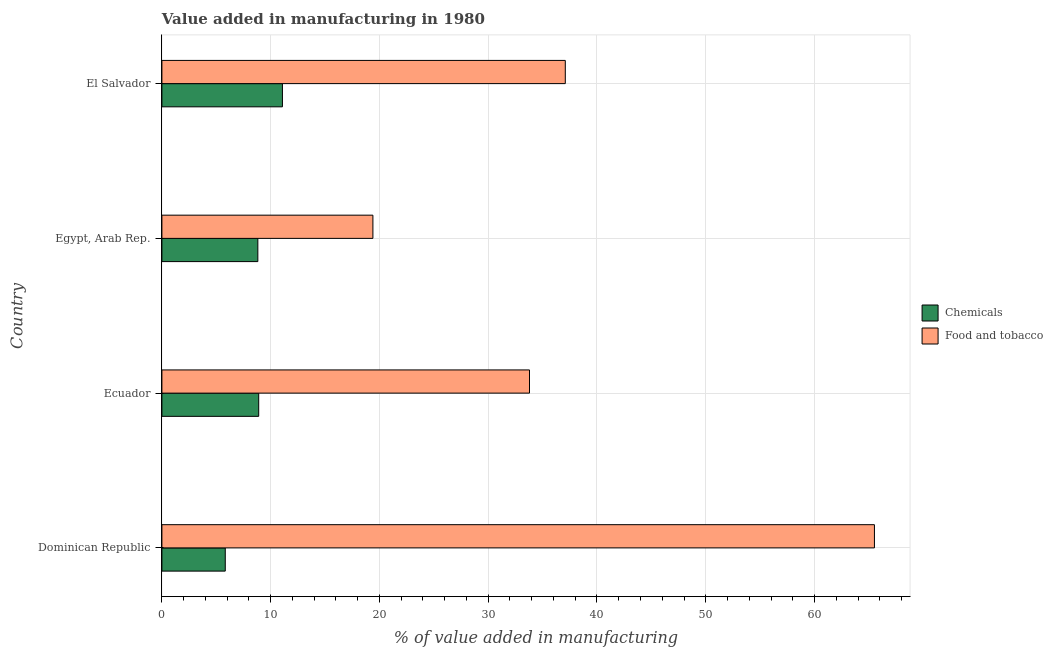How many groups of bars are there?
Make the answer very short. 4. Are the number of bars per tick equal to the number of legend labels?
Your answer should be compact. Yes. Are the number of bars on each tick of the Y-axis equal?
Your answer should be very brief. Yes. How many bars are there on the 1st tick from the top?
Your answer should be very brief. 2. What is the label of the 3rd group of bars from the top?
Offer a terse response. Ecuador. What is the value added by manufacturing food and tobacco in Egypt, Arab Rep.?
Provide a succinct answer. 19.4. Across all countries, what is the maximum value added by  manufacturing chemicals?
Offer a very short reply. 11.08. Across all countries, what is the minimum value added by  manufacturing chemicals?
Ensure brevity in your answer.  5.83. In which country was the value added by manufacturing food and tobacco maximum?
Ensure brevity in your answer.  Dominican Republic. In which country was the value added by  manufacturing chemicals minimum?
Your response must be concise. Dominican Republic. What is the total value added by  manufacturing chemicals in the graph?
Offer a very short reply. 34.63. What is the difference between the value added by manufacturing food and tobacco in Dominican Republic and that in Ecuador?
Keep it short and to the point. 31.71. What is the difference between the value added by manufacturing food and tobacco in Ecuador and the value added by  manufacturing chemicals in Egypt, Arab Rep.?
Provide a short and direct response. 24.98. What is the average value added by manufacturing food and tobacco per country?
Keep it short and to the point. 38.95. What is the difference between the value added by  manufacturing chemicals and value added by manufacturing food and tobacco in Egypt, Arab Rep.?
Offer a very short reply. -10.58. In how many countries, is the value added by  manufacturing chemicals greater than 56 %?
Your answer should be very brief. 0. What is the ratio of the value added by manufacturing food and tobacco in Dominican Republic to that in Ecuador?
Offer a terse response. 1.94. Is the value added by manufacturing food and tobacco in Dominican Republic less than that in Ecuador?
Your response must be concise. No. Is the difference between the value added by  manufacturing chemicals in Ecuador and Egypt, Arab Rep. greater than the difference between the value added by manufacturing food and tobacco in Ecuador and Egypt, Arab Rep.?
Provide a succinct answer. No. What is the difference between the highest and the second highest value added by manufacturing food and tobacco?
Make the answer very short. 28.42. What is the difference between the highest and the lowest value added by  manufacturing chemicals?
Give a very brief answer. 5.26. In how many countries, is the value added by  manufacturing chemicals greater than the average value added by  manufacturing chemicals taken over all countries?
Ensure brevity in your answer.  3. What does the 1st bar from the top in El Salvador represents?
Give a very brief answer. Food and tobacco. What does the 2nd bar from the bottom in Ecuador represents?
Your answer should be very brief. Food and tobacco. How many countries are there in the graph?
Ensure brevity in your answer.  4. What is the difference between two consecutive major ticks on the X-axis?
Make the answer very short. 10. Does the graph contain grids?
Make the answer very short. Yes. How many legend labels are there?
Keep it short and to the point. 2. How are the legend labels stacked?
Offer a very short reply. Vertical. What is the title of the graph?
Your answer should be very brief. Value added in manufacturing in 1980. What is the label or title of the X-axis?
Provide a succinct answer. % of value added in manufacturing. What is the label or title of the Y-axis?
Offer a very short reply. Country. What is the % of value added in manufacturing in Chemicals in Dominican Republic?
Offer a very short reply. 5.83. What is the % of value added in manufacturing in Food and tobacco in Dominican Republic?
Keep it short and to the point. 65.51. What is the % of value added in manufacturing in Chemicals in Ecuador?
Make the answer very short. 8.9. What is the % of value added in manufacturing in Food and tobacco in Ecuador?
Your answer should be compact. 33.8. What is the % of value added in manufacturing of Chemicals in Egypt, Arab Rep.?
Offer a very short reply. 8.82. What is the % of value added in manufacturing in Food and tobacco in Egypt, Arab Rep.?
Provide a short and direct response. 19.4. What is the % of value added in manufacturing of Chemicals in El Salvador?
Your response must be concise. 11.08. What is the % of value added in manufacturing of Food and tobacco in El Salvador?
Give a very brief answer. 37.09. Across all countries, what is the maximum % of value added in manufacturing in Chemicals?
Provide a short and direct response. 11.08. Across all countries, what is the maximum % of value added in manufacturing in Food and tobacco?
Offer a very short reply. 65.51. Across all countries, what is the minimum % of value added in manufacturing of Chemicals?
Give a very brief answer. 5.83. Across all countries, what is the minimum % of value added in manufacturing in Food and tobacco?
Give a very brief answer. 19.4. What is the total % of value added in manufacturing in Chemicals in the graph?
Offer a very short reply. 34.63. What is the total % of value added in manufacturing in Food and tobacco in the graph?
Give a very brief answer. 155.79. What is the difference between the % of value added in manufacturing in Chemicals in Dominican Republic and that in Ecuador?
Your response must be concise. -3.07. What is the difference between the % of value added in manufacturing of Food and tobacco in Dominican Republic and that in Ecuador?
Offer a terse response. 31.71. What is the difference between the % of value added in manufacturing in Chemicals in Dominican Republic and that in Egypt, Arab Rep.?
Keep it short and to the point. -3. What is the difference between the % of value added in manufacturing in Food and tobacco in Dominican Republic and that in Egypt, Arab Rep.?
Make the answer very short. 46.11. What is the difference between the % of value added in manufacturing of Chemicals in Dominican Republic and that in El Salvador?
Your answer should be compact. -5.26. What is the difference between the % of value added in manufacturing of Food and tobacco in Dominican Republic and that in El Salvador?
Your response must be concise. 28.42. What is the difference between the % of value added in manufacturing in Chemicals in Ecuador and that in Egypt, Arab Rep.?
Offer a very short reply. 0.08. What is the difference between the % of value added in manufacturing in Food and tobacco in Ecuador and that in Egypt, Arab Rep.?
Offer a terse response. 14.4. What is the difference between the % of value added in manufacturing of Chemicals in Ecuador and that in El Salvador?
Offer a very short reply. -2.18. What is the difference between the % of value added in manufacturing in Food and tobacco in Ecuador and that in El Salvador?
Your answer should be very brief. -3.29. What is the difference between the % of value added in manufacturing of Chemicals in Egypt, Arab Rep. and that in El Salvador?
Give a very brief answer. -2.26. What is the difference between the % of value added in manufacturing in Food and tobacco in Egypt, Arab Rep. and that in El Salvador?
Your answer should be very brief. -17.69. What is the difference between the % of value added in manufacturing in Chemicals in Dominican Republic and the % of value added in manufacturing in Food and tobacco in Ecuador?
Your answer should be compact. -27.97. What is the difference between the % of value added in manufacturing in Chemicals in Dominican Republic and the % of value added in manufacturing in Food and tobacco in Egypt, Arab Rep.?
Offer a very short reply. -13.57. What is the difference between the % of value added in manufacturing of Chemicals in Dominican Republic and the % of value added in manufacturing of Food and tobacco in El Salvador?
Your answer should be very brief. -31.26. What is the difference between the % of value added in manufacturing in Chemicals in Ecuador and the % of value added in manufacturing in Food and tobacco in Egypt, Arab Rep.?
Ensure brevity in your answer.  -10.5. What is the difference between the % of value added in manufacturing of Chemicals in Ecuador and the % of value added in manufacturing of Food and tobacco in El Salvador?
Make the answer very short. -28.19. What is the difference between the % of value added in manufacturing of Chemicals in Egypt, Arab Rep. and the % of value added in manufacturing of Food and tobacco in El Salvador?
Provide a short and direct response. -28.27. What is the average % of value added in manufacturing of Chemicals per country?
Make the answer very short. 8.66. What is the average % of value added in manufacturing in Food and tobacco per country?
Offer a terse response. 38.95. What is the difference between the % of value added in manufacturing in Chemicals and % of value added in manufacturing in Food and tobacco in Dominican Republic?
Provide a succinct answer. -59.68. What is the difference between the % of value added in manufacturing of Chemicals and % of value added in manufacturing of Food and tobacco in Ecuador?
Your answer should be compact. -24.9. What is the difference between the % of value added in manufacturing in Chemicals and % of value added in manufacturing in Food and tobacco in Egypt, Arab Rep.?
Give a very brief answer. -10.58. What is the difference between the % of value added in manufacturing of Chemicals and % of value added in manufacturing of Food and tobacco in El Salvador?
Give a very brief answer. -26.01. What is the ratio of the % of value added in manufacturing in Chemicals in Dominican Republic to that in Ecuador?
Make the answer very short. 0.65. What is the ratio of the % of value added in manufacturing in Food and tobacco in Dominican Republic to that in Ecuador?
Your answer should be very brief. 1.94. What is the ratio of the % of value added in manufacturing of Chemicals in Dominican Republic to that in Egypt, Arab Rep.?
Keep it short and to the point. 0.66. What is the ratio of the % of value added in manufacturing in Food and tobacco in Dominican Republic to that in Egypt, Arab Rep.?
Keep it short and to the point. 3.38. What is the ratio of the % of value added in manufacturing of Chemicals in Dominican Republic to that in El Salvador?
Ensure brevity in your answer.  0.53. What is the ratio of the % of value added in manufacturing in Food and tobacco in Dominican Republic to that in El Salvador?
Give a very brief answer. 1.77. What is the ratio of the % of value added in manufacturing in Food and tobacco in Ecuador to that in Egypt, Arab Rep.?
Provide a succinct answer. 1.74. What is the ratio of the % of value added in manufacturing of Chemicals in Ecuador to that in El Salvador?
Offer a very short reply. 0.8. What is the ratio of the % of value added in manufacturing in Food and tobacco in Ecuador to that in El Salvador?
Provide a short and direct response. 0.91. What is the ratio of the % of value added in manufacturing of Chemicals in Egypt, Arab Rep. to that in El Salvador?
Offer a terse response. 0.8. What is the ratio of the % of value added in manufacturing in Food and tobacco in Egypt, Arab Rep. to that in El Salvador?
Provide a succinct answer. 0.52. What is the difference between the highest and the second highest % of value added in manufacturing in Chemicals?
Make the answer very short. 2.18. What is the difference between the highest and the second highest % of value added in manufacturing in Food and tobacco?
Keep it short and to the point. 28.42. What is the difference between the highest and the lowest % of value added in manufacturing of Chemicals?
Offer a very short reply. 5.26. What is the difference between the highest and the lowest % of value added in manufacturing in Food and tobacco?
Your answer should be compact. 46.11. 